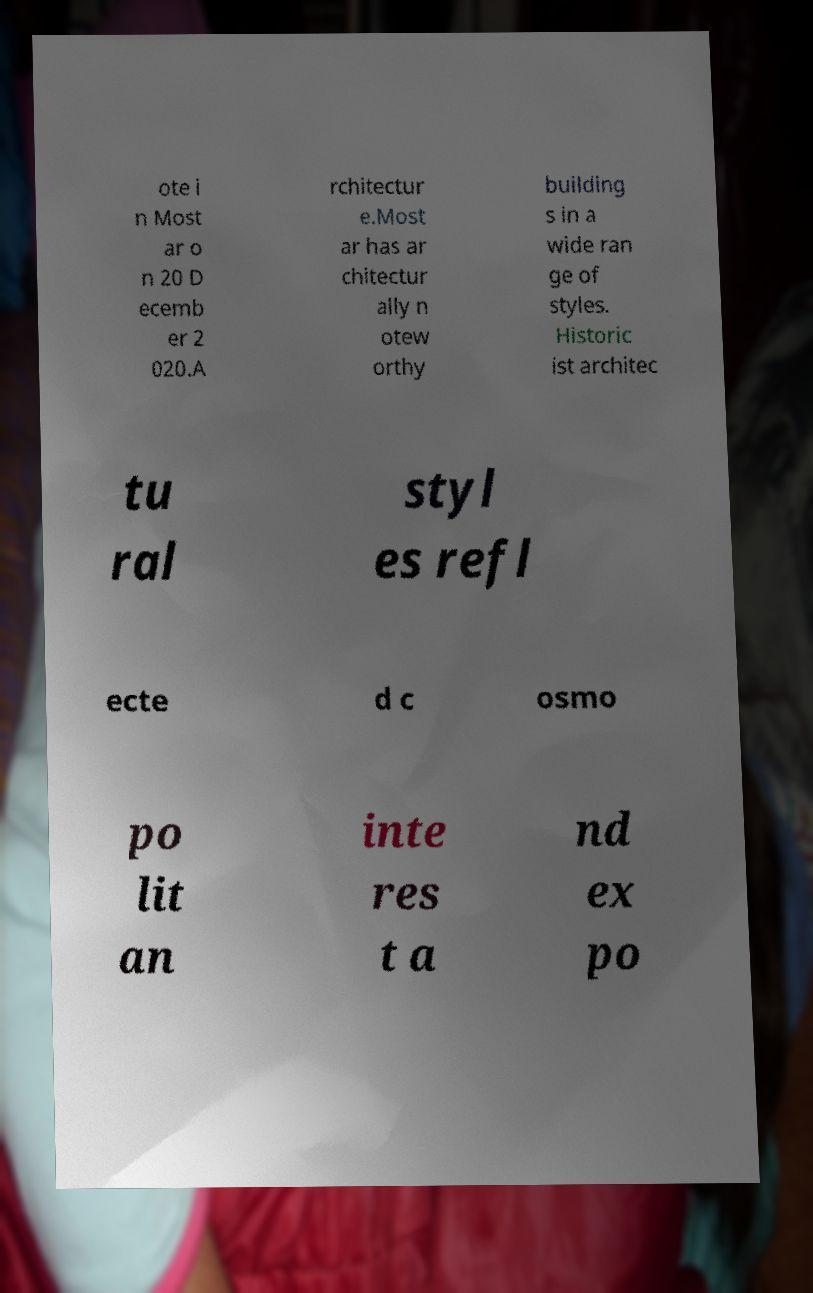Could you extract and type out the text from this image? ote i n Most ar o n 20 D ecemb er 2 020.A rchitectur e.Most ar has ar chitectur ally n otew orthy building s in a wide ran ge of styles. Historic ist architec tu ral styl es refl ecte d c osmo po lit an inte res t a nd ex po 